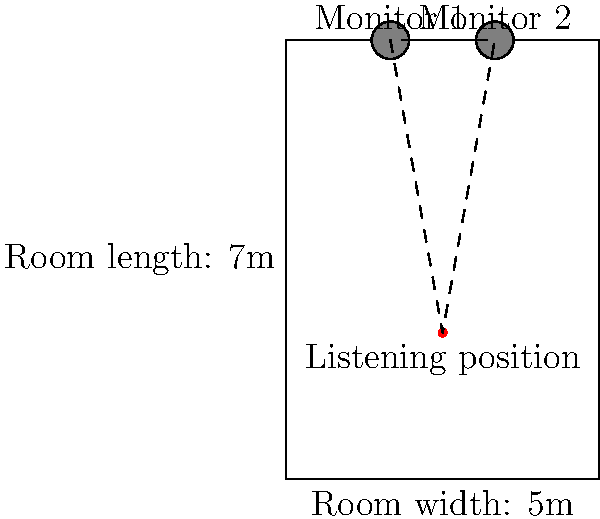In a rectangular recording studio with dimensions of 5m width and 7m length, what is the optimal distance between the studio monitors and the listening position to form an equilateral triangle, assuming the monitors are placed along the short wall? Round your answer to the nearest tenth of a meter. To find the optimal distance between the studio monitors and the listening position, we need to follow these steps:

1. Determine the distance between the monitors:
   - The monitors are placed on the short wall (5m wide)
   - Typically, monitors are placed at 1/3 and 2/3 of the wall width
   - Distance between monitors = $5m \times (2/3 - 1/3) = 5m \times 1/3 = 1.67m$

2. Calculate the side length of the equilateral triangle:
   - In an equilateral triangle, all sides are equal
   - The base of our triangle is the distance between monitors (1.67m)
   - Let's call the side length of the triangle $x$

3. Use the Pythagorean theorem to find the relationship between the base and side:
   $$(1.67/2)^2 + h^2 = x^2$$
   $$h^2 = x^2 - (1.67/2)^2$$

4. In an equilateral triangle, the height $h$ is related to the side length $x$ by:
   $$h = x \times \frac{\sqrt{3}}{2}$$

5. Substitute this into the Pythagorean theorem equation:
   $$(x \times \frac{\sqrt{3}}{2})^2 = x^2 - (1.67/2)^2$$

6. Solve for $x$:
   $$\frac{3x^2}{4} = x^2 - 0.695556$$
   $$0.695556 = x^2 - \frac{3x^2}{4} = \frac{x^2}{4}$$
   $$x^2 = 0.695556 \times 4 = 2.78224$$
   $$x = \sqrt{2.78224} \approx 1.67m$$

7. Round to the nearest tenth:
   1.67m rounds to 1.7m

Therefore, the optimal distance between the studio monitors and the listening position is approximately 1.7m.
Answer: 1.7m 